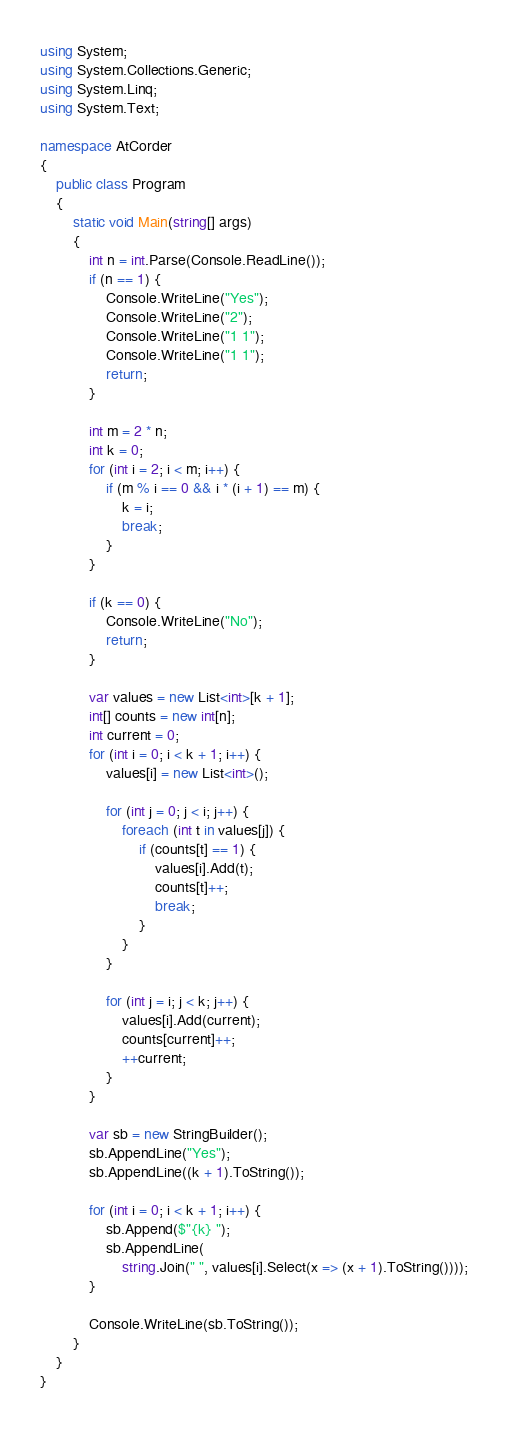<code> <loc_0><loc_0><loc_500><loc_500><_C#_>using System;
using System.Collections.Generic;
using System.Linq;
using System.Text;

namespace AtCorder
{
	public class Program
	{
		static void Main(string[] args)
		{
			int n = int.Parse(Console.ReadLine());
			if (n == 1) {
				Console.WriteLine("Yes");
				Console.WriteLine("2");
				Console.WriteLine("1 1");
				Console.WriteLine("1 1");
				return;
			}

			int m = 2 * n;
			int k = 0;
			for (int i = 2; i < m; i++) {
				if (m % i == 0 && i * (i + 1) == m) {
					k = i;
					break;
				}
			}

			if (k == 0) {
				Console.WriteLine("No");
				return;
			}

			var values = new List<int>[k + 1];
			int[] counts = new int[n];
			int current = 0;
			for (int i = 0; i < k + 1; i++) {
				values[i] = new List<int>();

				for (int j = 0; j < i; j++) {
					foreach (int t in values[j]) {
						if (counts[t] == 1) {
							values[i].Add(t);
							counts[t]++;
							break;
						}
					}
				}

				for (int j = i; j < k; j++) {
					values[i].Add(current);
					counts[current]++;
					++current;
				}
			}

			var sb = new StringBuilder();
			sb.AppendLine("Yes");
			sb.AppendLine((k + 1).ToString());

			for (int i = 0; i < k + 1; i++) {
				sb.Append($"{k} ");
				sb.AppendLine(
					string.Join(" ", values[i].Select(x => (x + 1).ToString())));
			}

			Console.WriteLine(sb.ToString());
		}
	}
}
</code> 